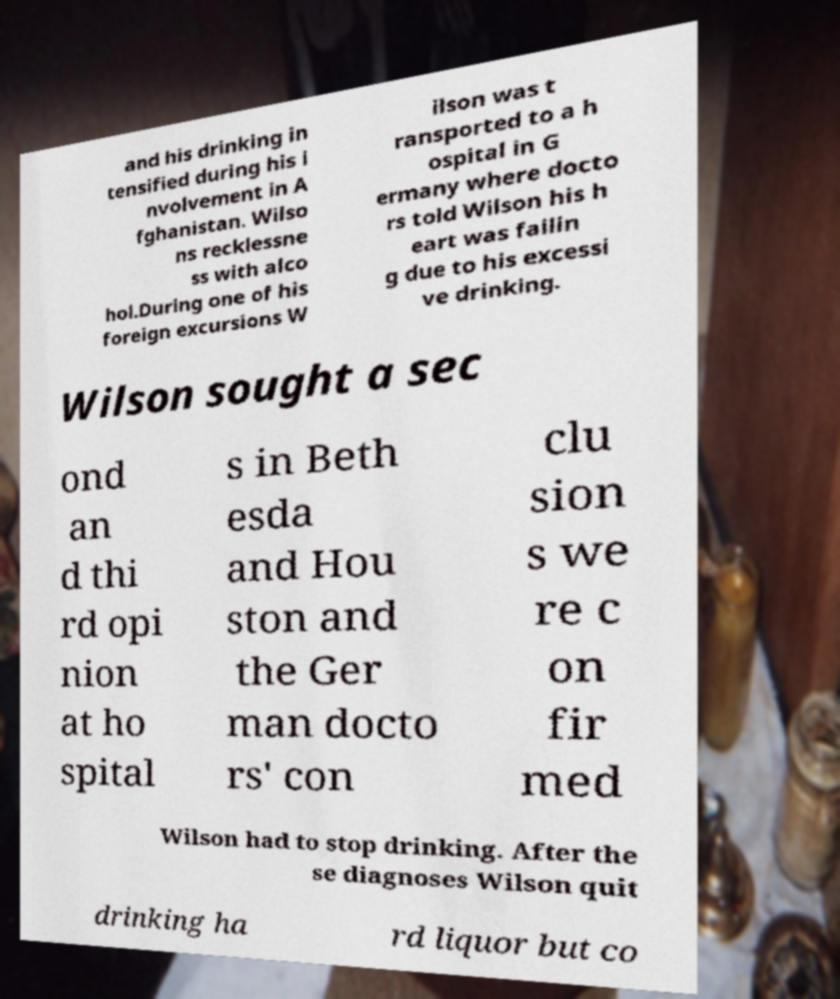There's text embedded in this image that I need extracted. Can you transcribe it verbatim? and his drinking in tensified during his i nvolvement in A fghanistan. Wilso ns recklessne ss with alco hol.During one of his foreign excursions W ilson was t ransported to a h ospital in G ermany where docto rs told Wilson his h eart was failin g due to his excessi ve drinking. Wilson sought a sec ond an d thi rd opi nion at ho spital s in Beth esda and Hou ston and the Ger man docto rs' con clu sion s we re c on fir med Wilson had to stop drinking. After the se diagnoses Wilson quit drinking ha rd liquor but co 